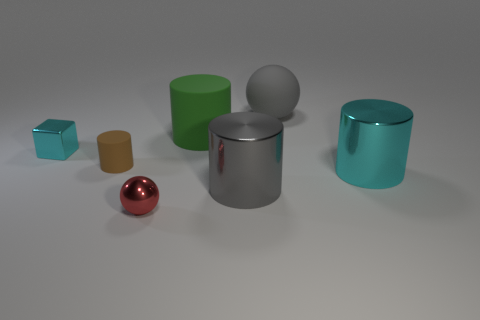Add 2 green cylinders. How many objects exist? 9 Subtract all large gray cylinders. How many cylinders are left? 3 Subtract 2 cylinders. How many cylinders are left? 2 Subtract all green cylinders. How many cylinders are left? 3 Subtract all cylinders. How many objects are left? 3 Add 4 small red shiny spheres. How many small red shiny spheres exist? 5 Subtract 0 blue cylinders. How many objects are left? 7 Subtract all cyan cylinders. Subtract all cyan balls. How many cylinders are left? 3 Subtract all big gray rubber balls. Subtract all big gray spheres. How many objects are left? 5 Add 2 cyan objects. How many cyan objects are left? 4 